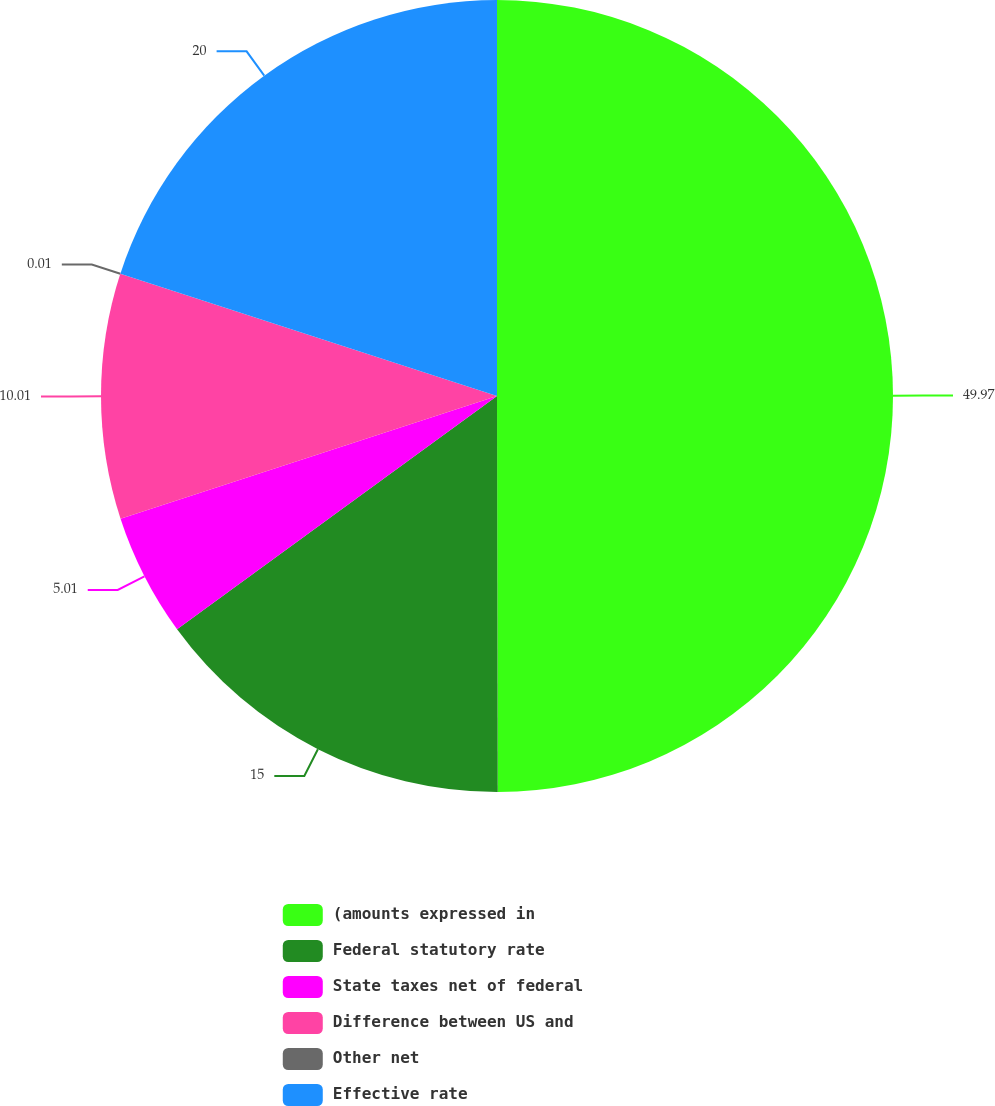Convert chart to OTSL. <chart><loc_0><loc_0><loc_500><loc_500><pie_chart><fcel>(amounts expressed in<fcel>Federal statutory rate<fcel>State taxes net of federal<fcel>Difference between US and<fcel>Other net<fcel>Effective rate<nl><fcel>49.97%<fcel>15.0%<fcel>5.01%<fcel>10.01%<fcel>0.01%<fcel>20.0%<nl></chart> 